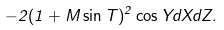<formula> <loc_0><loc_0><loc_500><loc_500>- 2 ( 1 + M \sin T ) ^ { 2 } \cos Y d X d Z .</formula> 